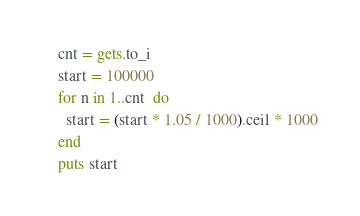Convert code to text. <code><loc_0><loc_0><loc_500><loc_500><_Ruby_>cnt = gets.to_i
start = 100000
for n in 1..cnt  do
  start = (start * 1.05 / 1000).ceil * 1000
end
puts start</code> 